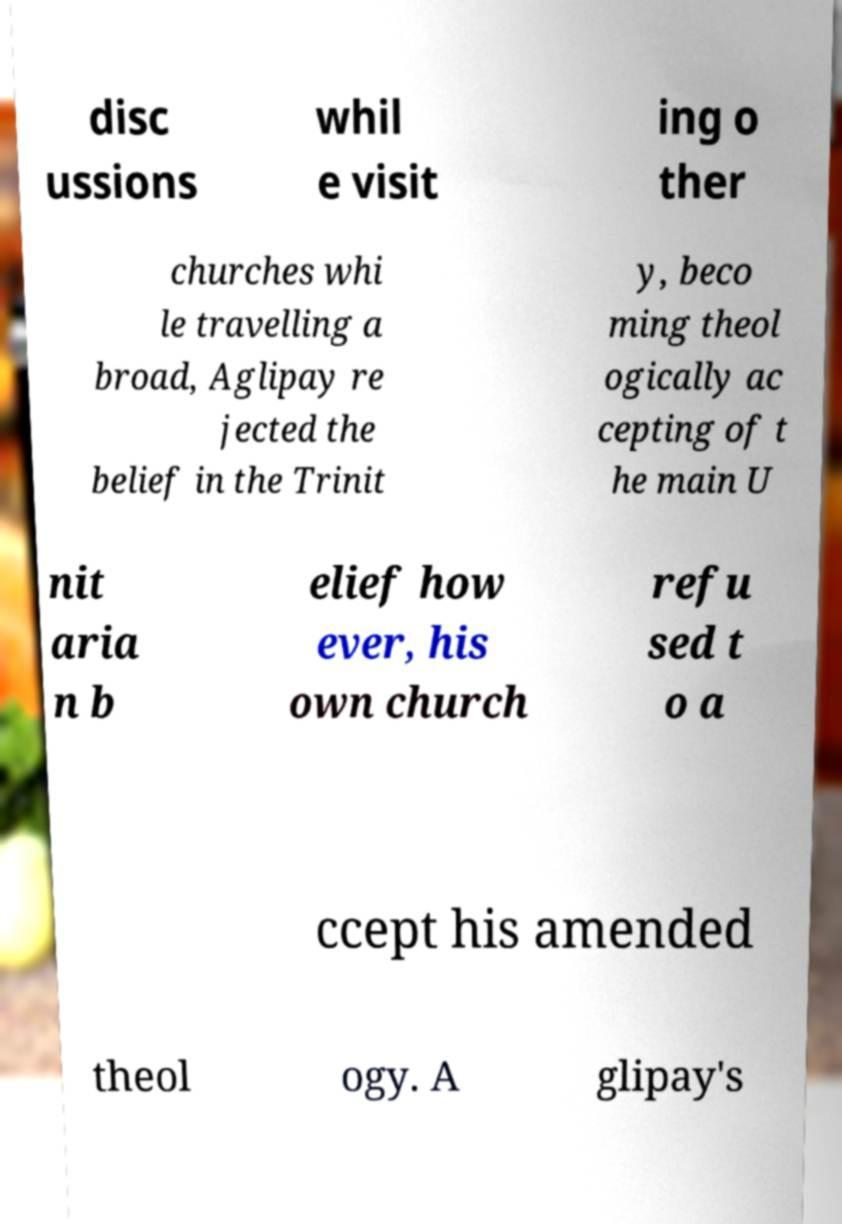Could you extract and type out the text from this image? disc ussions whil e visit ing o ther churches whi le travelling a broad, Aglipay re jected the belief in the Trinit y, beco ming theol ogically ac cepting of t he main U nit aria n b elief how ever, his own church refu sed t o a ccept his amended theol ogy. A glipay's 